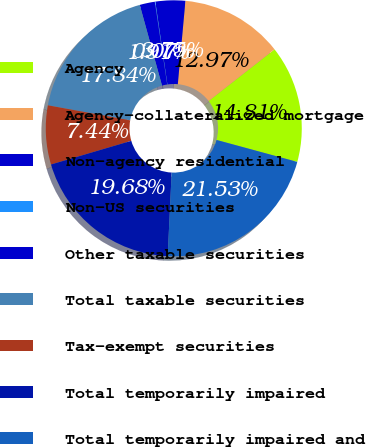Convert chart. <chart><loc_0><loc_0><loc_500><loc_500><pie_chart><fcel>Agency<fcel>Agency-collateralized mortgage<fcel>Non-agency residential<fcel>Non-US securities<fcel>Other taxable securities<fcel>Total taxable securities<fcel>Tax-exempt securities<fcel>Total temporarily impaired<fcel>Total temporarily impaired and<nl><fcel>14.81%<fcel>12.97%<fcel>3.75%<fcel>0.07%<fcel>1.91%<fcel>17.84%<fcel>7.44%<fcel>19.68%<fcel>21.53%<nl></chart> 